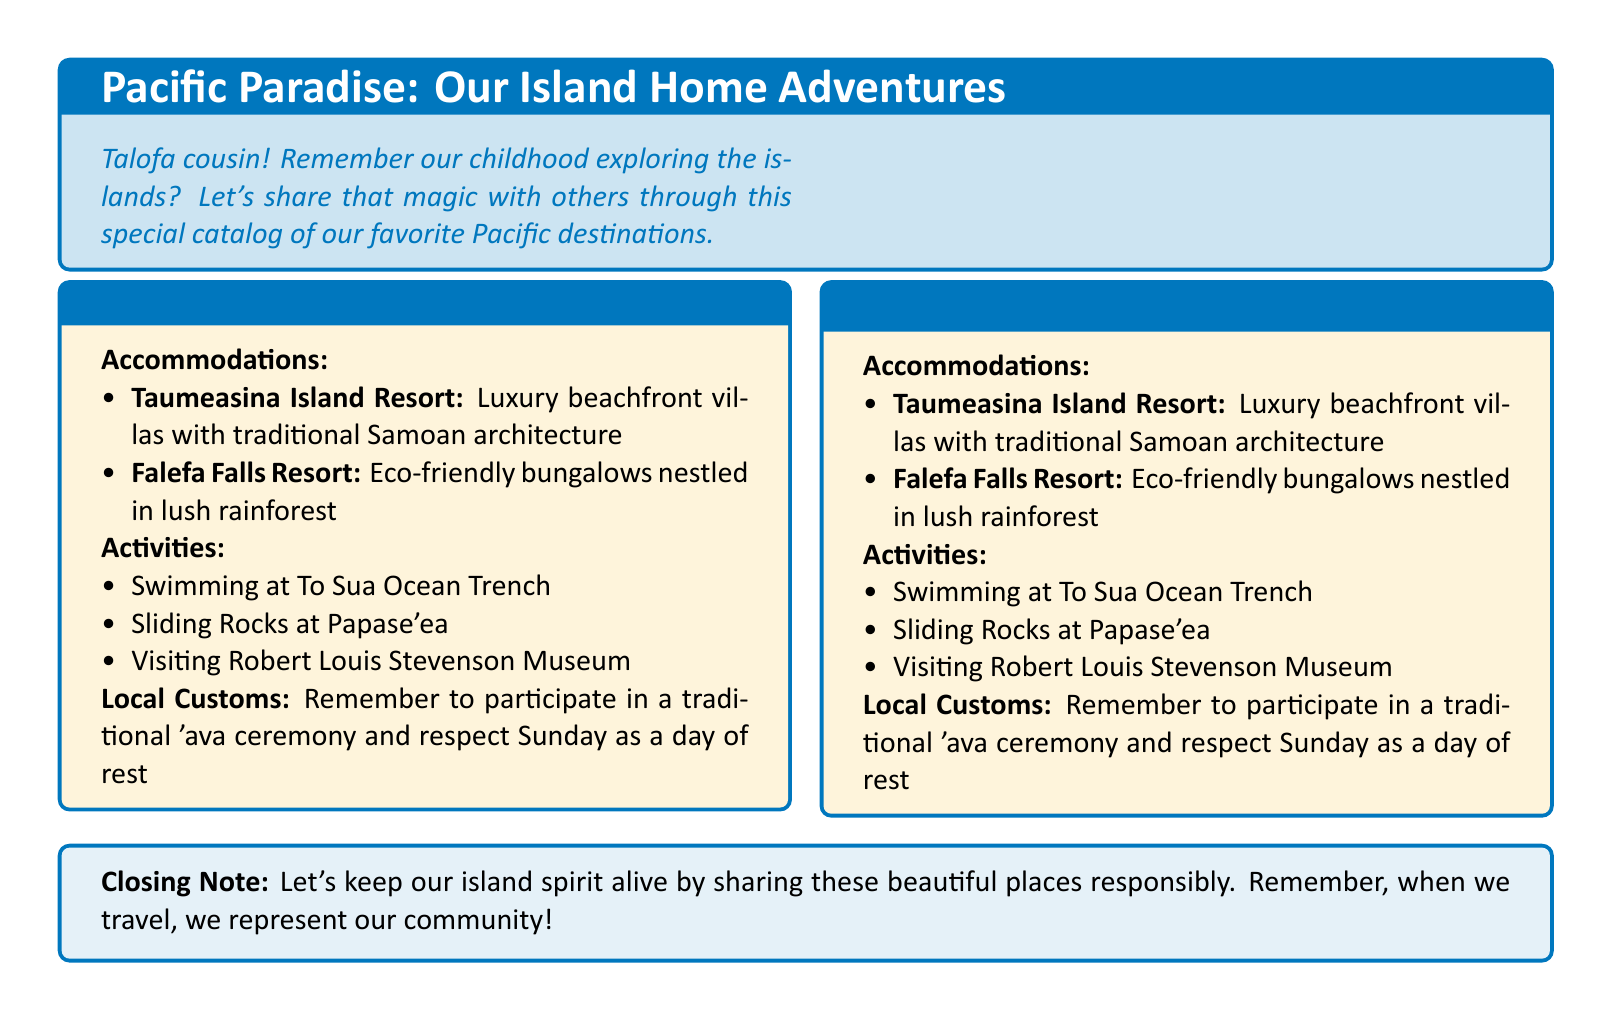What are the names of the destinations discussed? The destinations mentioned in the document are Samoa and Fiji.
Answer: Samoa, Fiji What is one accommodation option in Samoa? The document lists two accommodations for Samoa, one of which is Taumeasina Island Resort.
Answer: Taumeasina Island Resort What is a local custom to participate in when visiting Samoa? The document states that visitors should participate in a traditional 'ava ceremony.
Answer: 'ava ceremony What type of resort is Falefa Falls Resort? The document describes Falefa Falls Resort as eco-friendly.
Answer: Eco-friendly How many activities are listed for Samoa? There are three activities mentioned for Samoa.
Answer: Three What is a special note mentioned at the end of the document? The closing note encourages sharing the beauty of the places responsibly and representing the community.
Answer: Share responsibly What architectural style does Taumeasina Island Resort feature? The document highlights that Taumeasina Island Resort has traditional Samoan architecture.
Answer: Traditional Samoan architecture What is the theme of the catalog? The primary theme of the catalog is to share experiences from Pacific Island destinations.
Answer: Island home adventures 